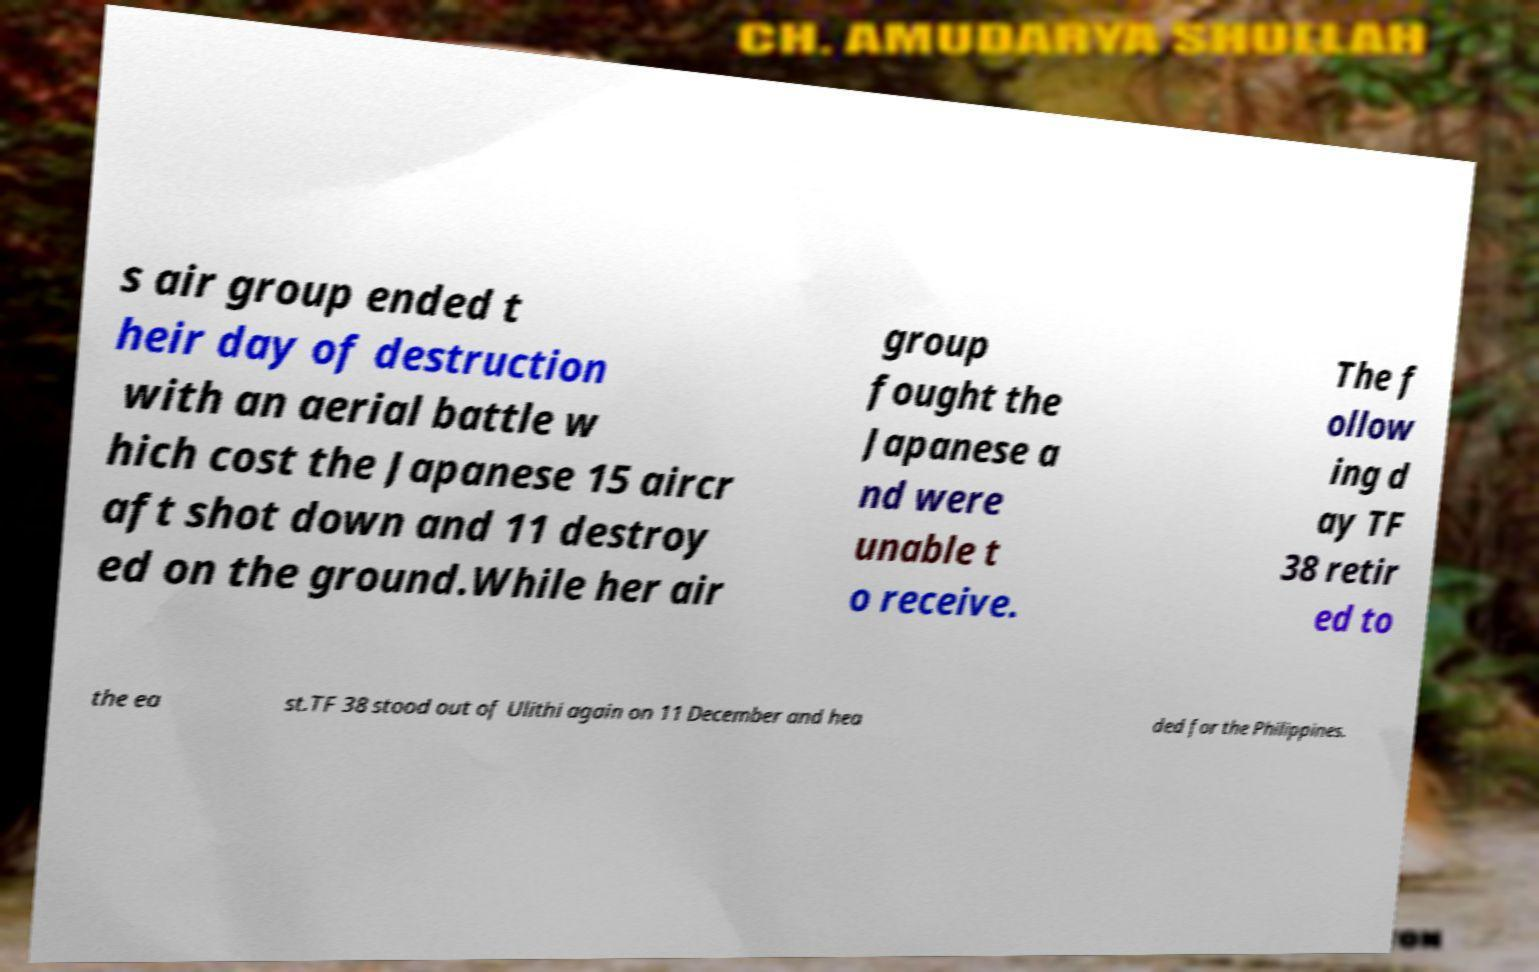For documentation purposes, I need the text within this image transcribed. Could you provide that? s air group ended t heir day of destruction with an aerial battle w hich cost the Japanese 15 aircr aft shot down and 11 destroy ed on the ground.While her air group fought the Japanese a nd were unable t o receive. The f ollow ing d ay TF 38 retir ed to the ea st.TF 38 stood out of Ulithi again on 11 December and hea ded for the Philippines. 